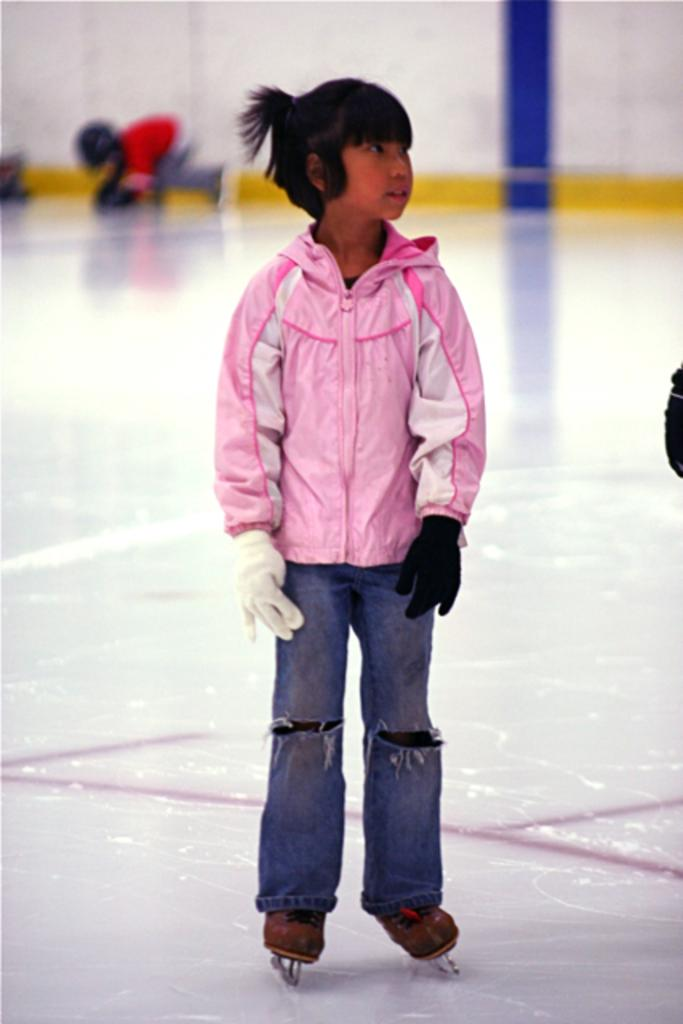Who is the main subject in the picture? There is a girl in the picture. Where is the girl located in the image? The girl is in the middle of the image. What type of shoes is the girl wearing? The girl is wearing ice skating shoes. What surface is the girl standing on? The girl is standing on an ice skating rink. How many rabbits can be seen holding yarn in the image? There are no rabbits or yarn present in the image. 